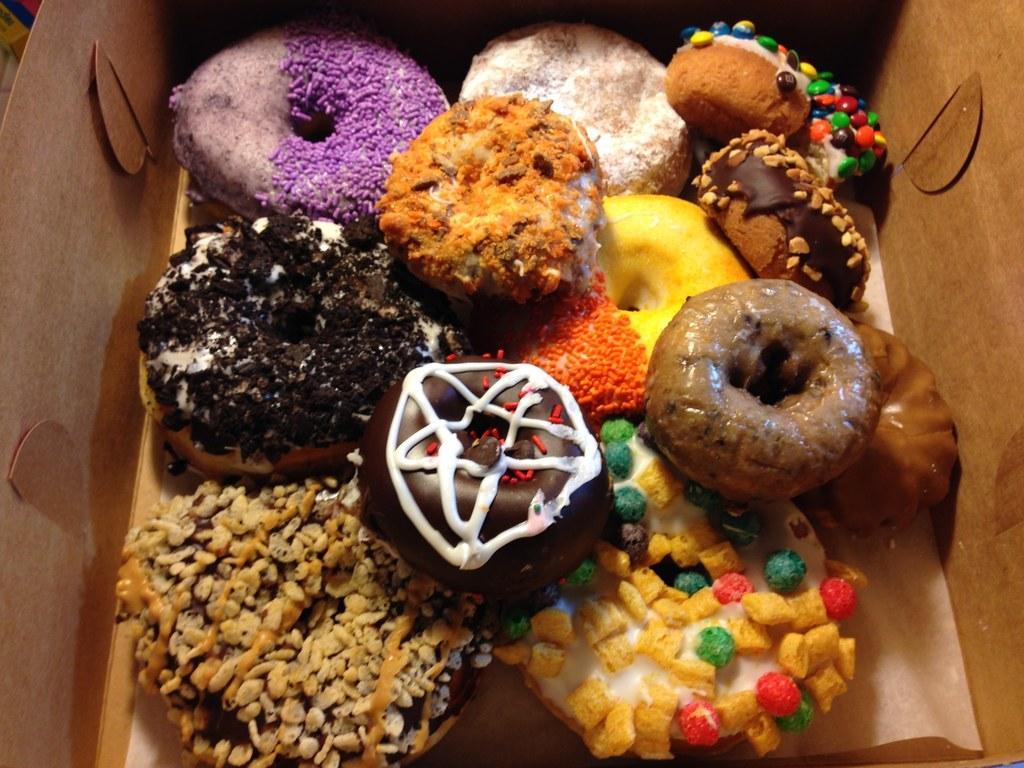Describe this image in one or two sentences. In the image there is a cardboard box with different types and colors of doughnuts. 